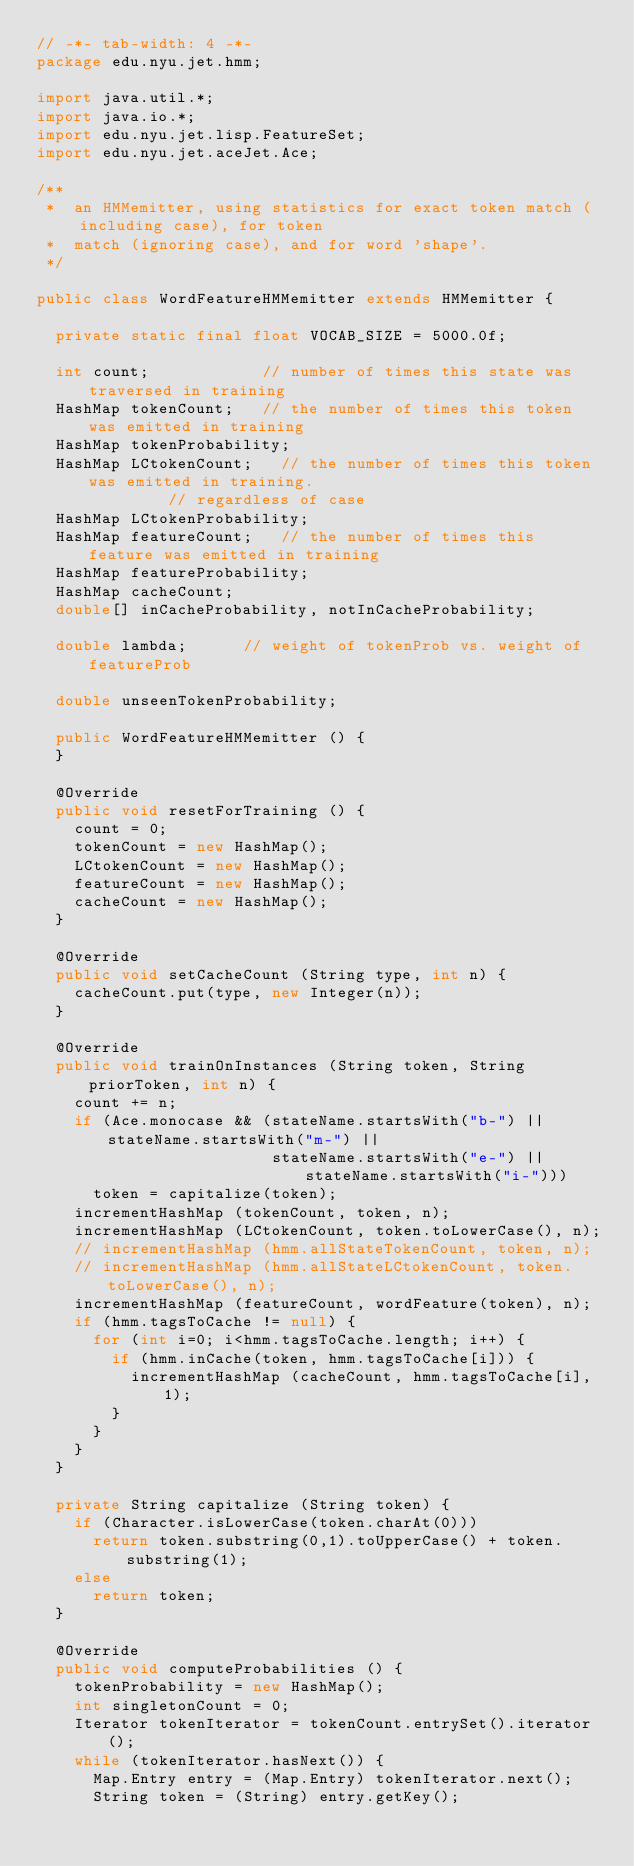Convert code to text. <code><loc_0><loc_0><loc_500><loc_500><_Java_>// -*- tab-width: 4 -*-
package edu.nyu.jet.hmm;

import java.util.*;
import java.io.*;
import edu.nyu.jet.lisp.FeatureSet;
import edu.nyu.jet.aceJet.Ace;

/**
 *  an HMMemitter, using statistics for exact token match (including case), for token
 *  match (ignoring case), and for word 'shape'.
 */

public class WordFeatureHMMemitter extends HMMemitter {

	private static final float VOCAB_SIZE = 5000.0f;

	int count;           	// number of times this state was traversed in training
	HashMap tokenCount;  	// the number of times this token was emitted in training
	HashMap tokenProbability;
	HashMap LCtokenCount;  	// the number of times this token was emitted in training.
							// regardless of case
	HashMap LCtokenProbability;
	HashMap featureCount;  	// the number of times this feature was emitted in training
	HashMap featureProbability;
	HashMap cacheCount;
	double[] inCacheProbability, notInCacheProbability;

	double lambda;			// weight of tokenProb vs. weight of featureProb

	double unseenTokenProbability;

	public WordFeatureHMMemitter () {
	}

	@Override
	public void resetForTraining () {
		count = 0;
		tokenCount = new HashMap();
		LCtokenCount = new HashMap();
		featureCount = new HashMap();
		cacheCount = new HashMap();
	}

	@Override
	public void setCacheCount (String type, int n) {
		cacheCount.put(type, new Integer(n));
	}

	@Override
	public void trainOnInstances (String token, String priorToken, int n) {
		count += n;
		if (Ace.monocase && (stateName.startsWith("b-") || stateName.startsWith("m-") ||
		                     stateName.startsWith("e-") || stateName.startsWith("i-")))
			token = capitalize(token);
		incrementHashMap (tokenCount, token, n);
		incrementHashMap (LCtokenCount, token.toLowerCase(), n);
		// incrementHashMap (hmm.allStateTokenCount, token, n);
		// incrementHashMap (hmm.allStateLCtokenCount, token.toLowerCase(), n);
		incrementHashMap (featureCount, wordFeature(token), n);
		if (hmm.tagsToCache != null) {
			for (int i=0; i<hmm.tagsToCache.length; i++) {
				if (hmm.inCache(token, hmm.tagsToCache[i])) {
					incrementHashMap (cacheCount, hmm.tagsToCache[i], 1);
				}
			}
		}
	}

	private String capitalize (String token) {
		if (Character.isLowerCase(token.charAt(0)))
			return token.substring(0,1).toUpperCase() + token.substring(1);
		else
			return token;
	}

	@Override
	public void computeProbabilities () {
		tokenProbability = new HashMap();
		int singletonCount = 0;
		Iterator tokenIterator = tokenCount.entrySet().iterator();
		while (tokenIterator.hasNext()) {
			Map.Entry entry = (Map.Entry) tokenIterator.next();
			String token = (String) entry.getKey();</code> 